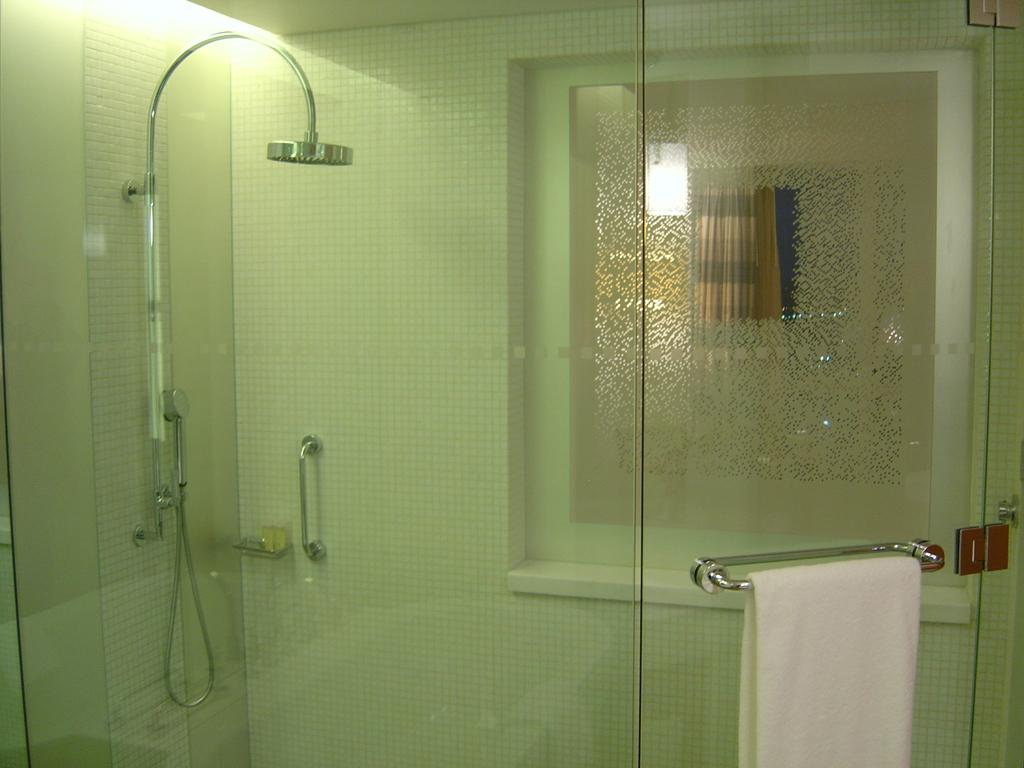What type of room is shown in the image? The image depicts a bathroom. What can be seen on the right side of the image? There is a white color towel on the right side of the image. What feature is commonly found in bathrooms and is present in the image? There is a shower in the image. What type of shade is covering the window in the image? There is no window or shade present in the image. Can you see a cat in the image? There is no cat present in the image. What type of fruit is on the counter in the image? There is no fruit, specifically a pear, present in the image. 